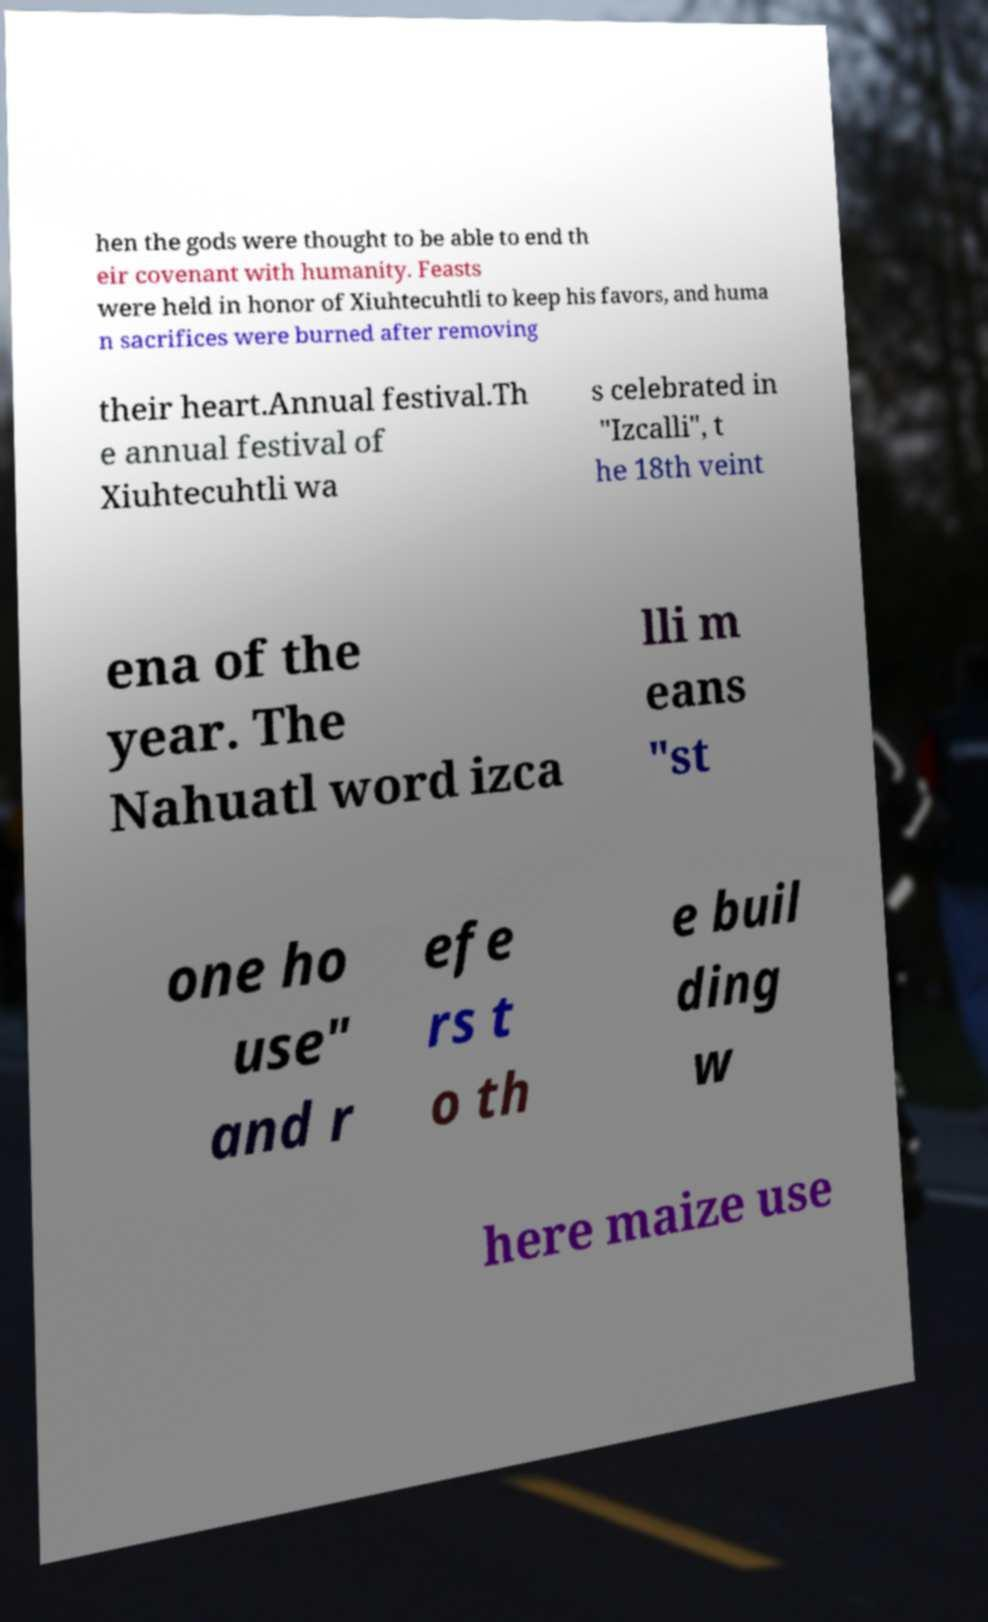I need the written content from this picture converted into text. Can you do that? hen the gods were thought to be able to end th eir covenant with humanity. Feasts were held in honor of Xiuhtecuhtli to keep his favors, and huma n sacrifices were burned after removing their heart.Annual festival.Th e annual festival of Xiuhtecuhtli wa s celebrated in "Izcalli", t he 18th veint ena of the year. The Nahuatl word izca lli m eans "st one ho use" and r efe rs t o th e buil ding w here maize use 